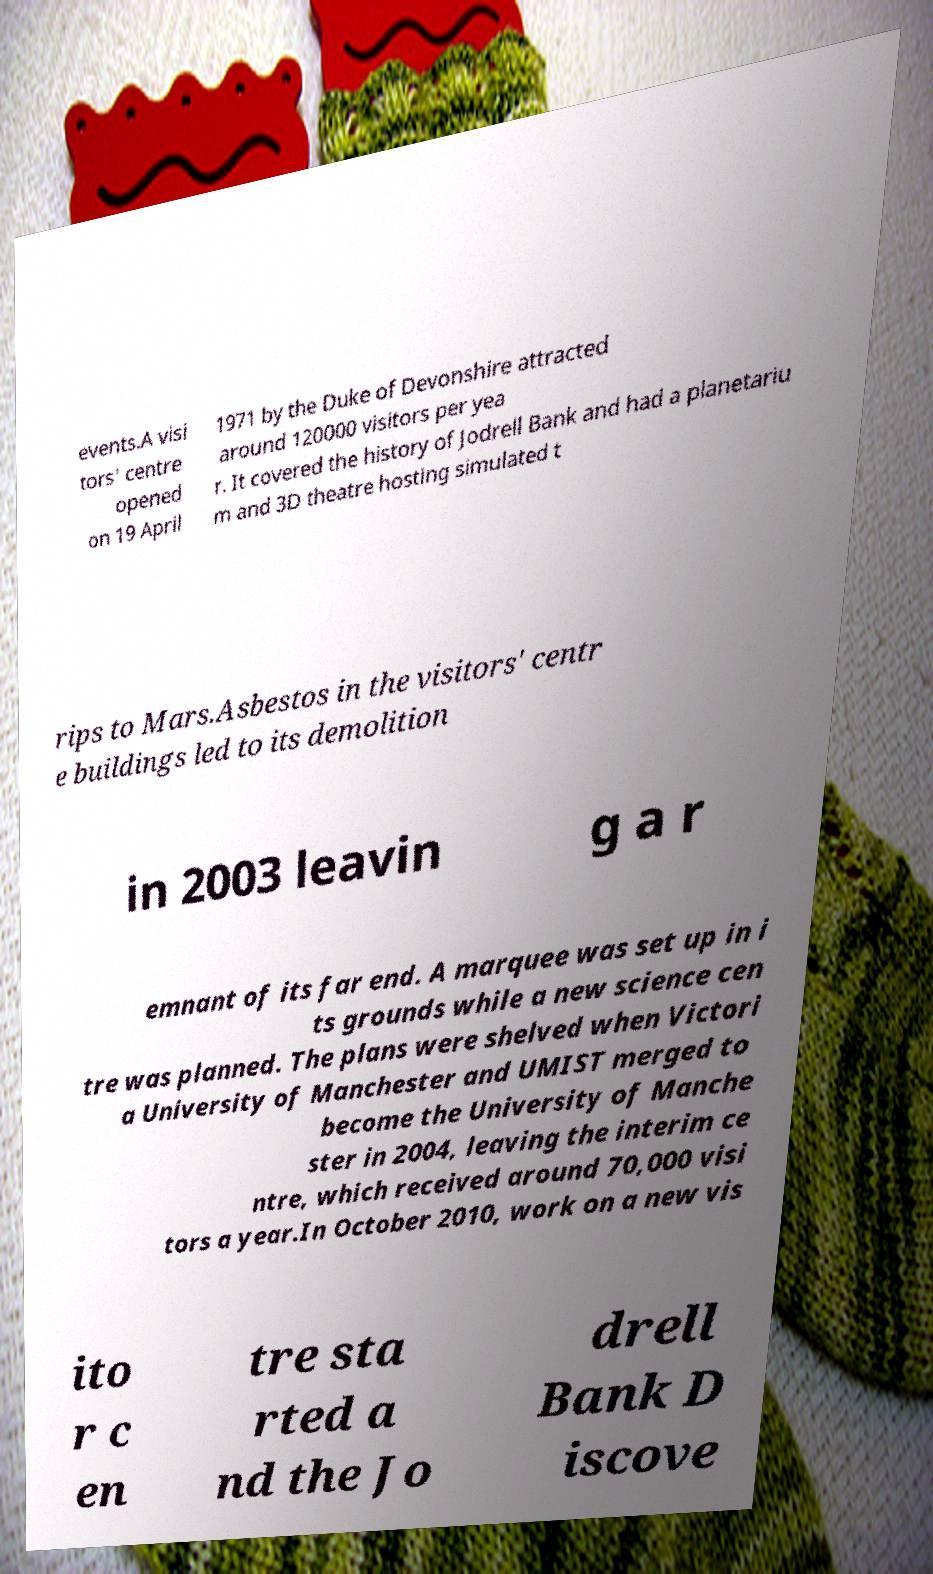What messages or text are displayed in this image? I need them in a readable, typed format. events.A visi tors' centre opened on 19 April 1971 by the Duke of Devonshire attracted around 120000 visitors per yea r. It covered the history of Jodrell Bank and had a planetariu m and 3D theatre hosting simulated t rips to Mars.Asbestos in the visitors' centr e buildings led to its demolition in 2003 leavin g a r emnant of its far end. A marquee was set up in i ts grounds while a new science cen tre was planned. The plans were shelved when Victori a University of Manchester and UMIST merged to become the University of Manche ster in 2004, leaving the interim ce ntre, which received around 70,000 visi tors a year.In October 2010, work on a new vis ito r c en tre sta rted a nd the Jo drell Bank D iscove 